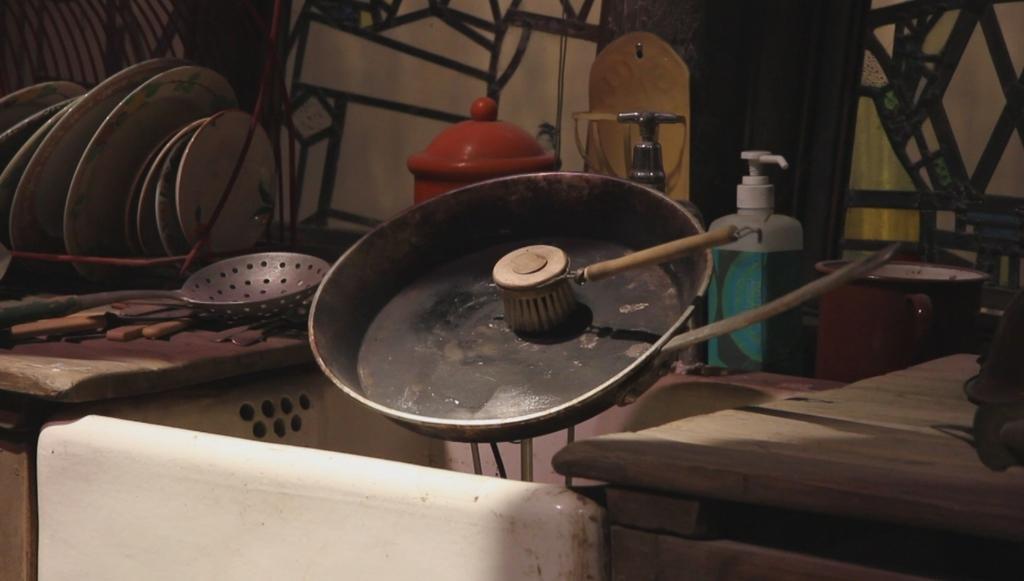How would you summarize this image in a sentence or two? The picture of kitchen. The plates are in stand. The plates are designed with flowers and it is in white color. Few spoons are on table. These is sink. Pan is getting cleaned with brush. Hand wash bottle. Tap. The container is for cooking. The table is made of wood. 